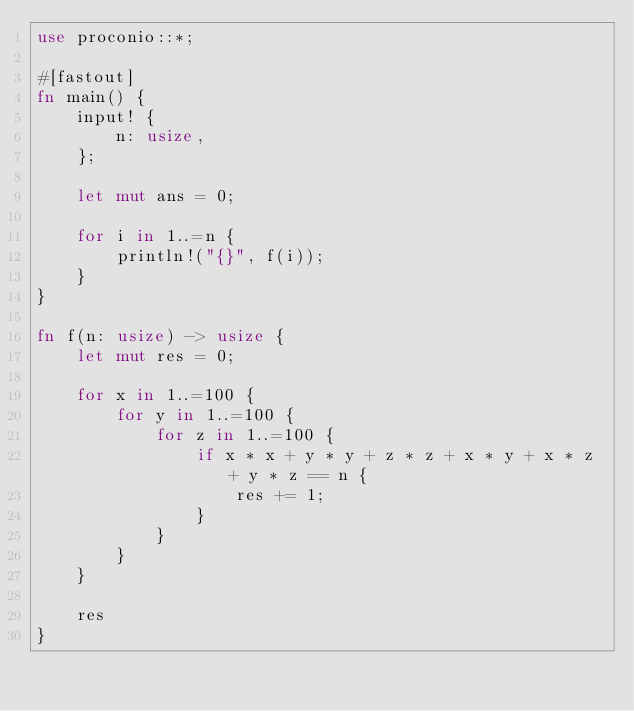Convert code to text. <code><loc_0><loc_0><loc_500><loc_500><_Rust_>use proconio::*;

#[fastout]
fn main() {
    input! {
        n: usize,
    };

    let mut ans = 0;

    for i in 1..=n {
        println!("{}", f(i));
    }
}

fn f(n: usize) -> usize {
    let mut res = 0;

    for x in 1..=100 {
        for y in 1..=100 {
            for z in 1..=100 {
                if x * x + y * y + z * z + x * y + x * z + y * z == n {
                    res += 1;
                }
            }
        }
    }

    res
}
</code> 